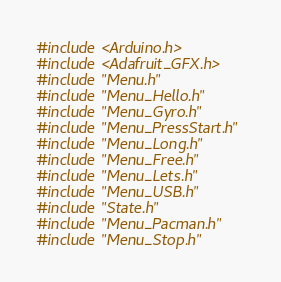<code> <loc_0><loc_0><loc_500><loc_500><_C++_>#include <Arduino.h>
#include <Adafruit_GFX.h>
#include "Menu.h"
#include "Menu_Hello.h"
#include "Menu_Gyro.h"
#include "Menu_PressStart.h"
#include "Menu_Long.h"
#include "Menu_Free.h"
#include "Menu_Lets.h"
#include "Menu_USB.h"
#include "State.h"
#include "Menu_Pacman.h"
#include "Menu_Stop.h"</code> 